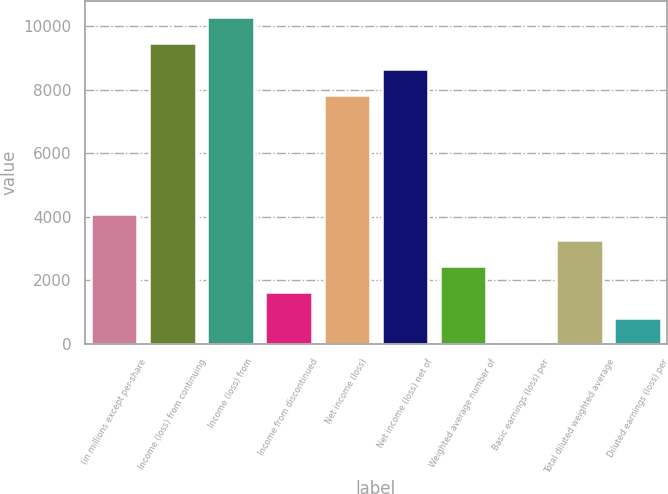Convert chart to OTSL. <chart><loc_0><loc_0><loc_500><loc_500><bar_chart><fcel>(in millions except per-share<fcel>Income (loss) from continuing<fcel>Income (loss) from<fcel>Income from discontinued<fcel>Net income (loss)<fcel>Net income (loss) net of<fcel>Weighted average number of<fcel>Basic earnings (loss) per<fcel>Total diluted weighted average<fcel>Diluted earnings (loss) per<nl><fcel>4078.13<fcel>9456.16<fcel>10269.7<fcel>1637.39<fcel>7829<fcel>8642.58<fcel>2450.97<fcel>10.23<fcel>3264.55<fcel>823.81<nl></chart> 